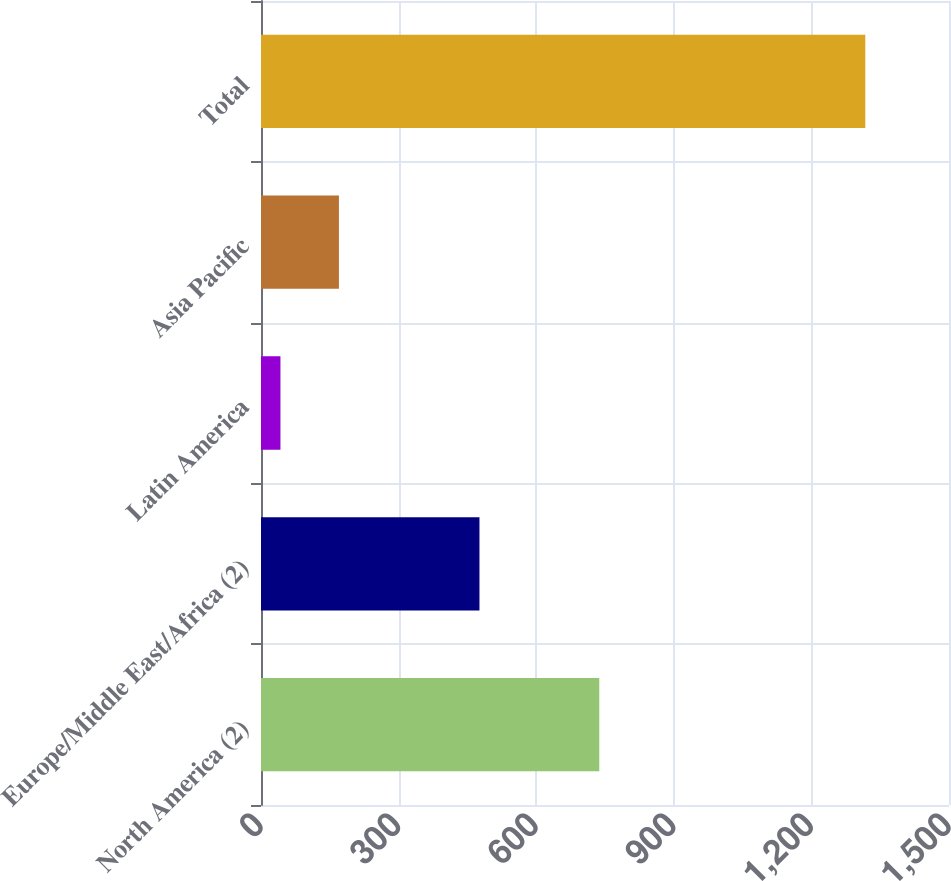Convert chart. <chart><loc_0><loc_0><loc_500><loc_500><bar_chart><fcel>North America (2)<fcel>Europe/Middle East/Africa (2)<fcel>Latin America<fcel>Asia Pacific<fcel>Total<nl><fcel>737.5<fcel>476.3<fcel>42.4<fcel>169.91<fcel>1317.5<nl></chart> 